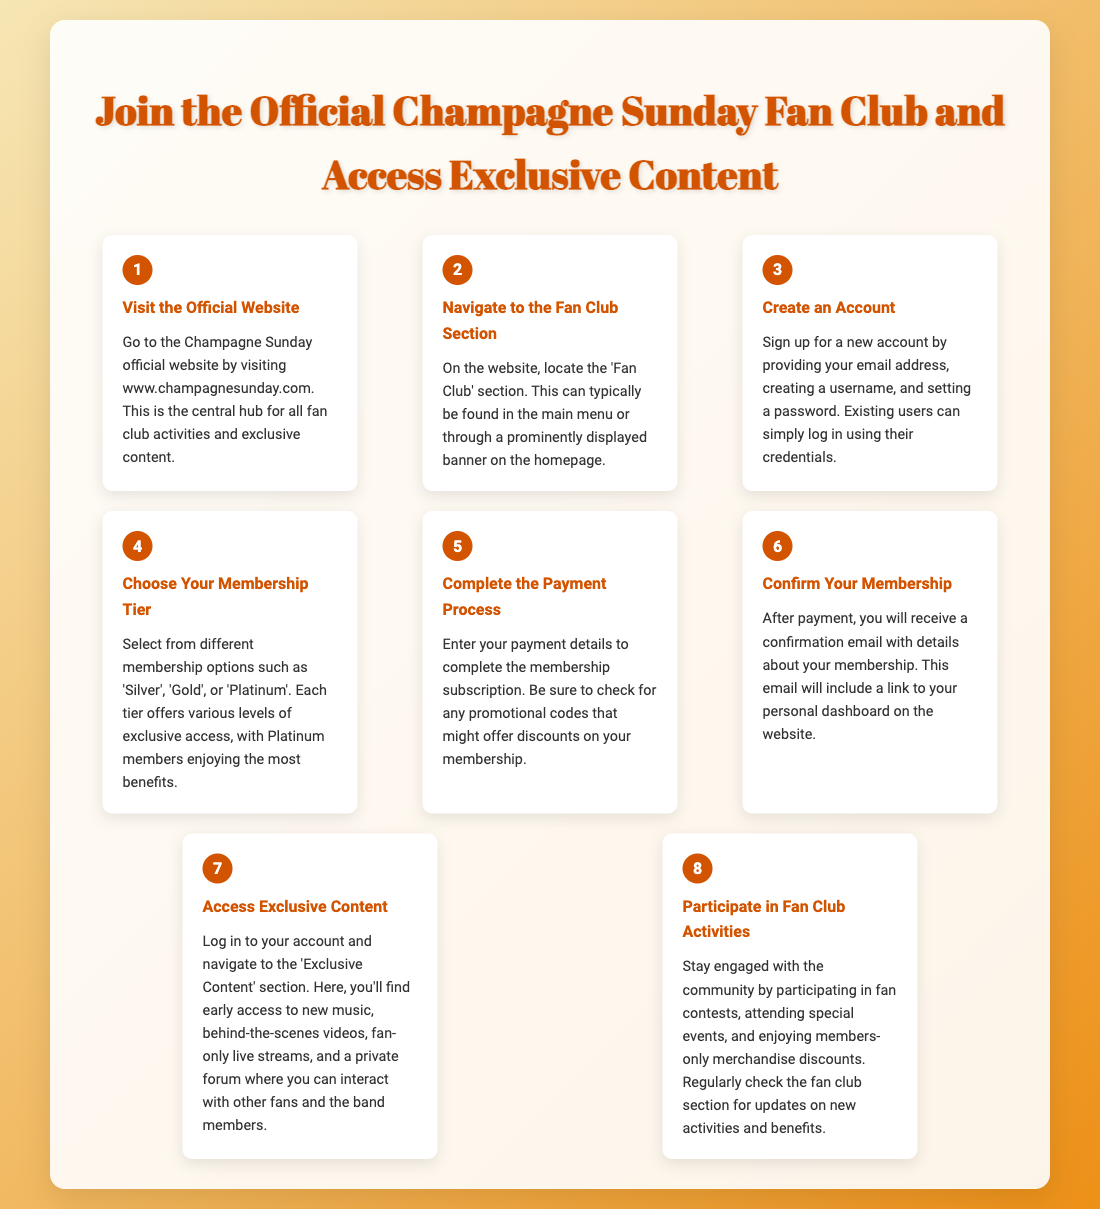What is the first step to join the fan club? The first step is to visit the official website at www.champagnesunday.com.
Answer: Visit the Official Website How many membership tiers are available? The document mentions three tiers: Silver, Gold, and Platinum.
Answer: Three What do you have to do after completing the payment process? After payment, you will receive a confirmation email with details about your membership.
Answer: Confirm Your Membership What kind of exclusive content can members access? Members can access early music, behind-the-scenes videos, live streams, and a private forum.
Answer: Early music, behind-the-scenes videos, live streams, private forum What is required to create an account? To create an account, you need to provide your email address, create a username, and set a password.
Answer: Email address, username, password What must you do to confirm your membership? To confirm your membership, you need to check your email for a confirmation email.
Answer: Check your email for a confirmation email What opportunities do fans have for engagement within the fan club? Fans can participate in contests, attend events, and enjoy merchandise discounts.
Answer: Contests, events, merchandise discounts Where can you find the fan club section on the website? The fan club section can typically be found in the main menu or on the homepage banner.
Answer: Main menu or homepage banner 